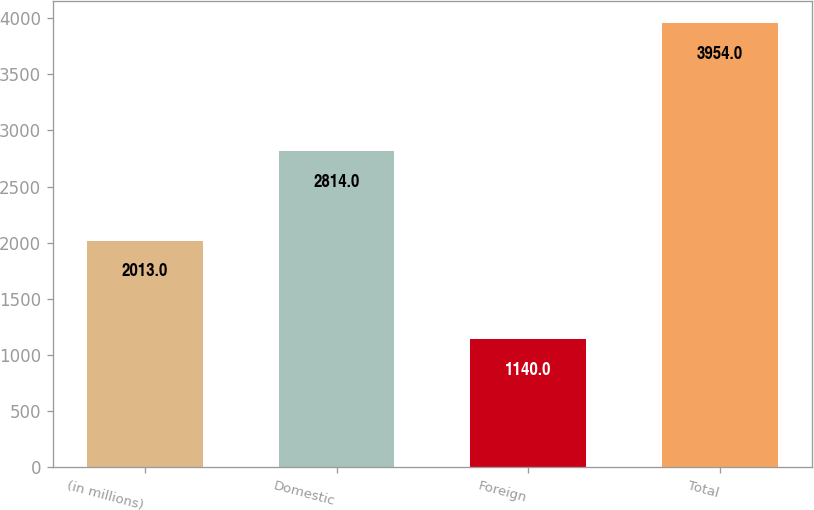Convert chart. <chart><loc_0><loc_0><loc_500><loc_500><bar_chart><fcel>(in millions)<fcel>Domestic<fcel>Foreign<fcel>Total<nl><fcel>2013<fcel>2814<fcel>1140<fcel>3954<nl></chart> 